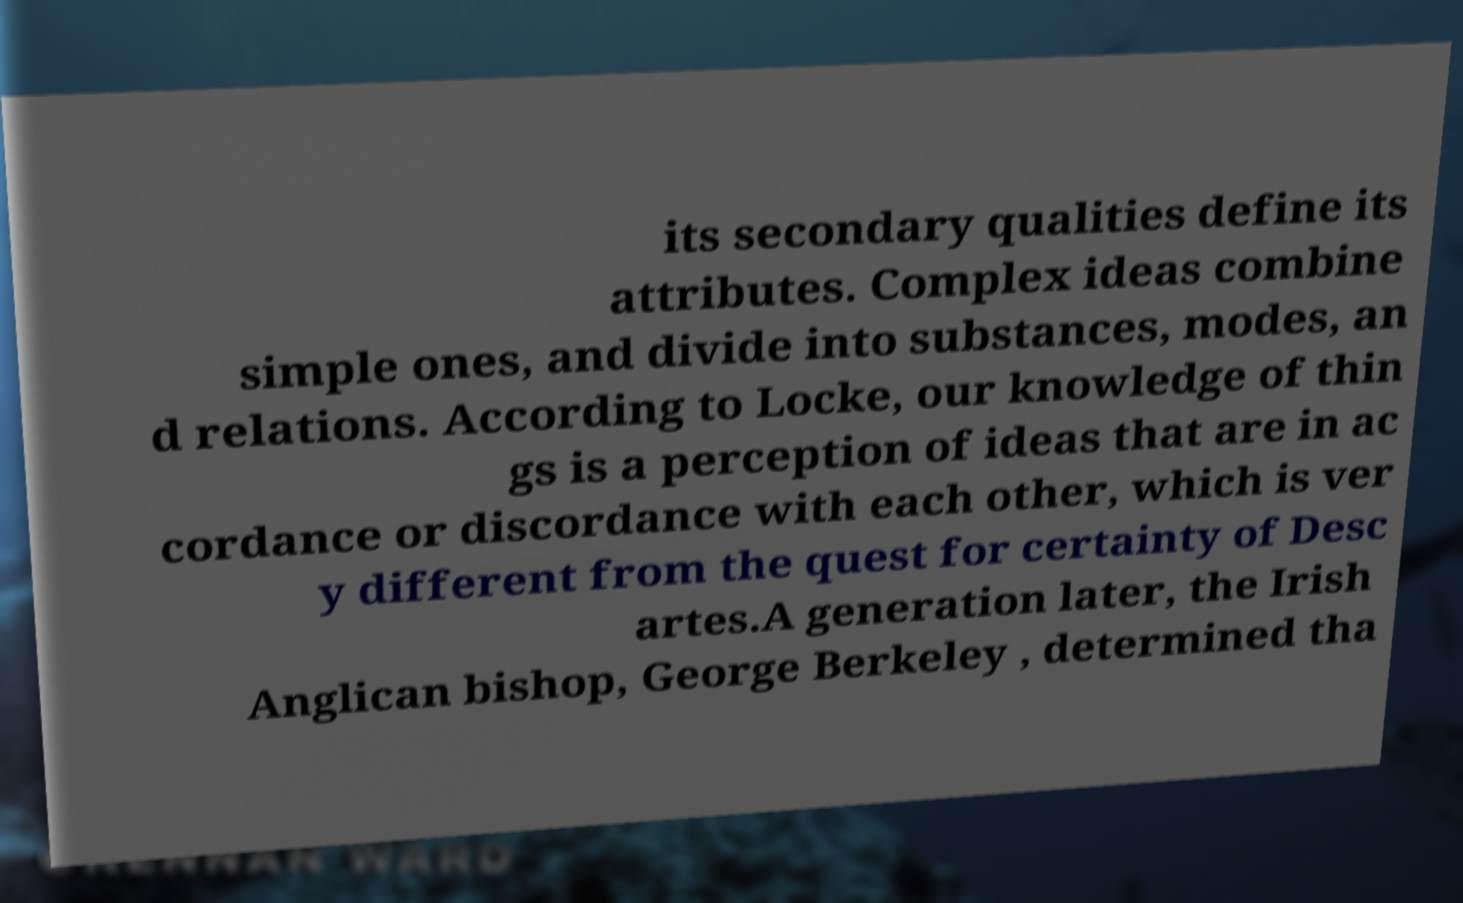What messages or text are displayed in this image? I need them in a readable, typed format. its secondary qualities define its attributes. Complex ideas combine simple ones, and divide into substances, modes, an d relations. According to Locke, our knowledge of thin gs is a perception of ideas that are in ac cordance or discordance with each other, which is ver y different from the quest for certainty of Desc artes.A generation later, the Irish Anglican bishop, George Berkeley , determined tha 